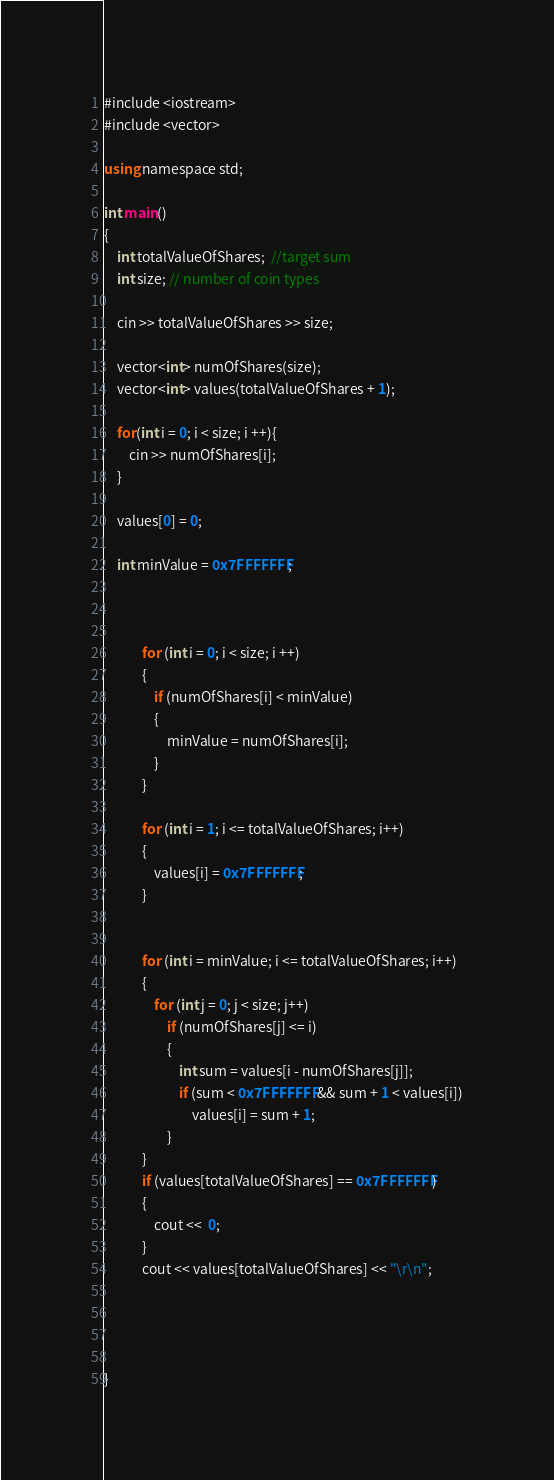<code> <loc_0><loc_0><loc_500><loc_500><_C#_>
#include <iostream>
#include <vector> 

using namespace std;

int main()
{
    int totalValueOfShares;  //target sum
    int size; // number of coin types
    
    cin >> totalValueOfShares >> size;
    
    vector<int> numOfShares(size);
    vector<int> values(totalValueOfShares + 1);
    
    for(int i = 0; i < size; i ++){
        cin >> numOfShares[i];
    }
    
    values[0] = 0;
    
    int minValue = 0x7FFFFFFF;
    
   

            for (int i = 0; i < size; i ++)
            {
                if (numOfShares[i] < minValue)
                {
                    minValue = numOfShares[i];
                }
            }

            for (int i = 1; i <= totalValueOfShares; i++)
            {
                values[i] = 0x7FFFFFFF;
            }


            for (int i = minValue; i <= totalValueOfShares; i++)
            {
                for (int j = 0; j < size; j++)
                    if (numOfShares[j] <= i)
                    {
                        int sum = values[i - numOfShares[j]];
                        if (sum < 0x7FFFFFFF && sum + 1 < values[i])
                            values[i] = sum + 1;
                    }
            }
            if (values[totalValueOfShares] == 0x7FFFFFFF)
            {
                cout <<  0;
            }
            cout << values[totalValueOfShares] << "\r\n";    
    
    

    
}
</code> 